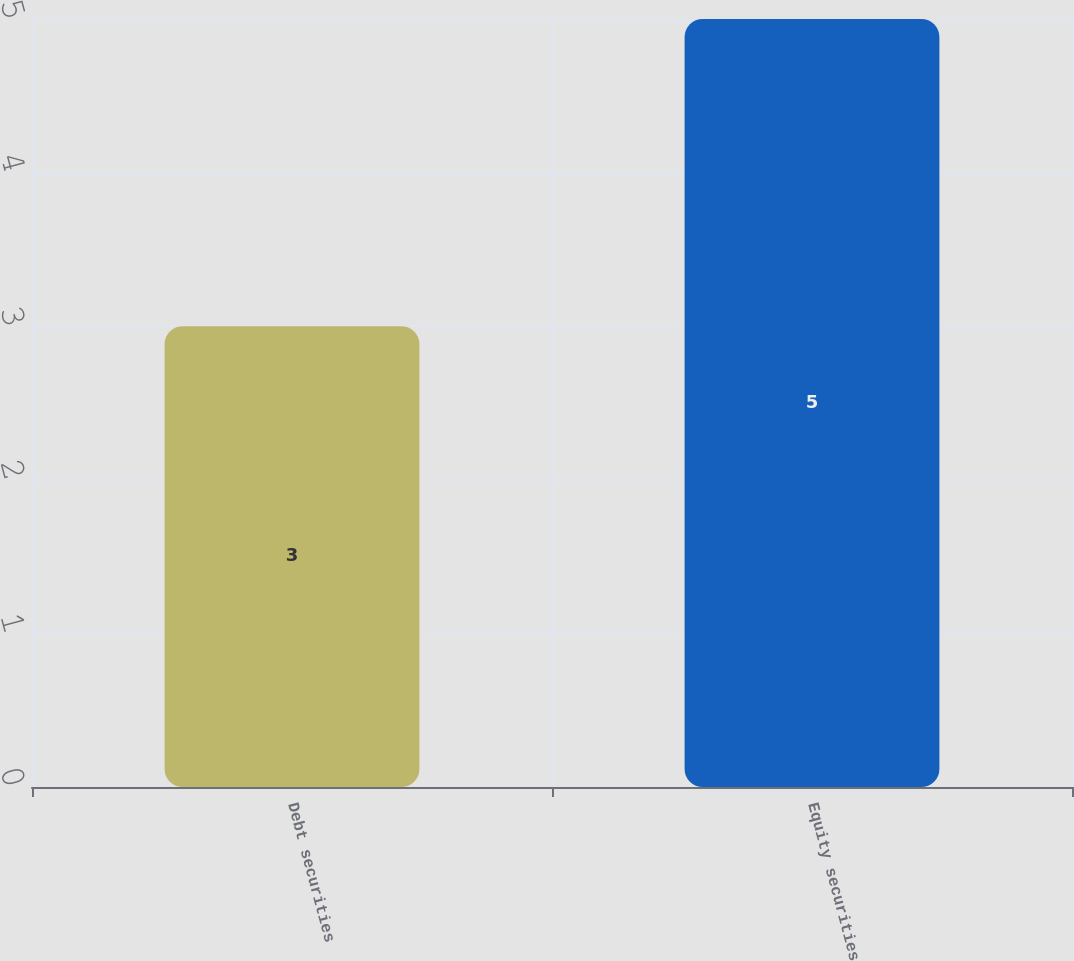Convert chart. <chart><loc_0><loc_0><loc_500><loc_500><bar_chart><fcel>Debt securities<fcel>Equity securities<nl><fcel>3<fcel>5<nl></chart> 